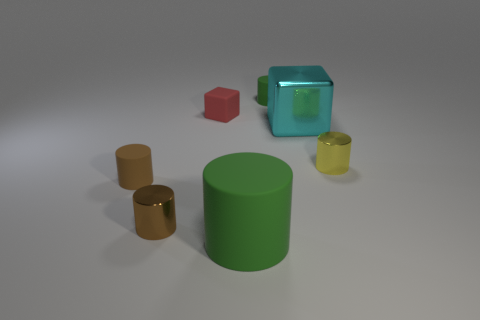What shape is the other object that is the same color as the large matte object?
Keep it short and to the point. Cylinder. There is a big thing to the right of the green object that is behind the small red matte thing; are there any tiny brown shiny objects right of it?
Offer a very short reply. No. Is the number of green cylinders that are in front of the brown matte cylinder less than the number of rubber things to the right of the small red cube?
Give a very brief answer. Yes. The big green thing that is the same material as the red object is what shape?
Your response must be concise. Cylinder. There is a green rubber object that is in front of the matte cylinder behind the matte thing that is to the left of the small brown shiny object; what size is it?
Offer a very short reply. Large. Is the number of small rubber objects greater than the number of gray matte cubes?
Give a very brief answer. Yes. Do the tiny matte thing that is in front of the tiny yellow metallic cylinder and the metal object to the left of the big cyan thing have the same color?
Your answer should be very brief. Yes. Do the green thing in front of the tiny yellow cylinder and the large cube that is on the right side of the brown metallic cylinder have the same material?
Your response must be concise. No. How many matte things have the same size as the brown rubber cylinder?
Keep it short and to the point. 2. Is the number of brown shiny cylinders less than the number of big purple blocks?
Make the answer very short. No. 